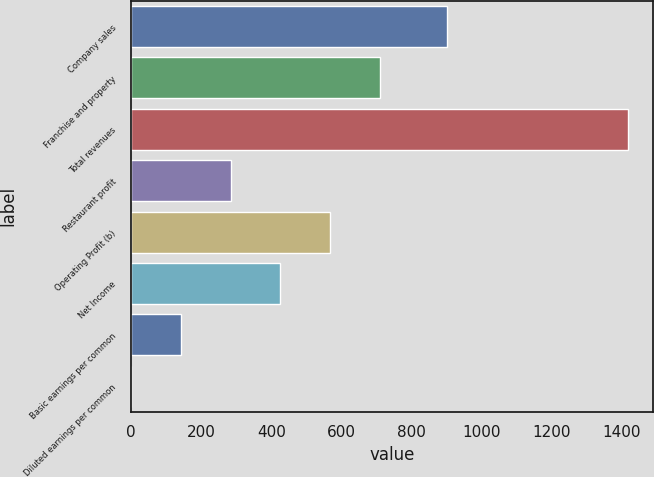<chart> <loc_0><loc_0><loc_500><loc_500><bar_chart><fcel>Company sales<fcel>Franchise and property<fcel>Total revenues<fcel>Restaurant profit<fcel>Operating Profit (b)<fcel>Net Income<fcel>Basic earnings per common<fcel>Diluted earnings per common<nl><fcel>902<fcel>708.87<fcel>1417<fcel>284.01<fcel>567.25<fcel>425.63<fcel>142.39<fcel>0.77<nl></chart> 